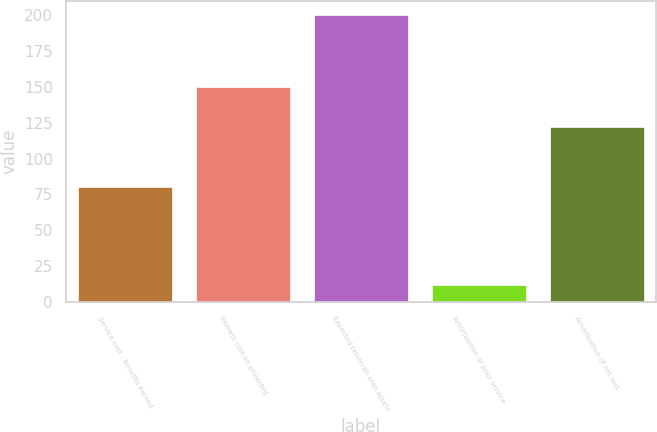<chart> <loc_0><loc_0><loc_500><loc_500><bar_chart><fcel>Service cost - benefits earned<fcel>Interest cost on projected<fcel>Expected return on plan assets<fcel>Amortization of prior service<fcel>Amortization of net loss<nl><fcel>80<fcel>150<fcel>200<fcel>12<fcel>122<nl></chart> 